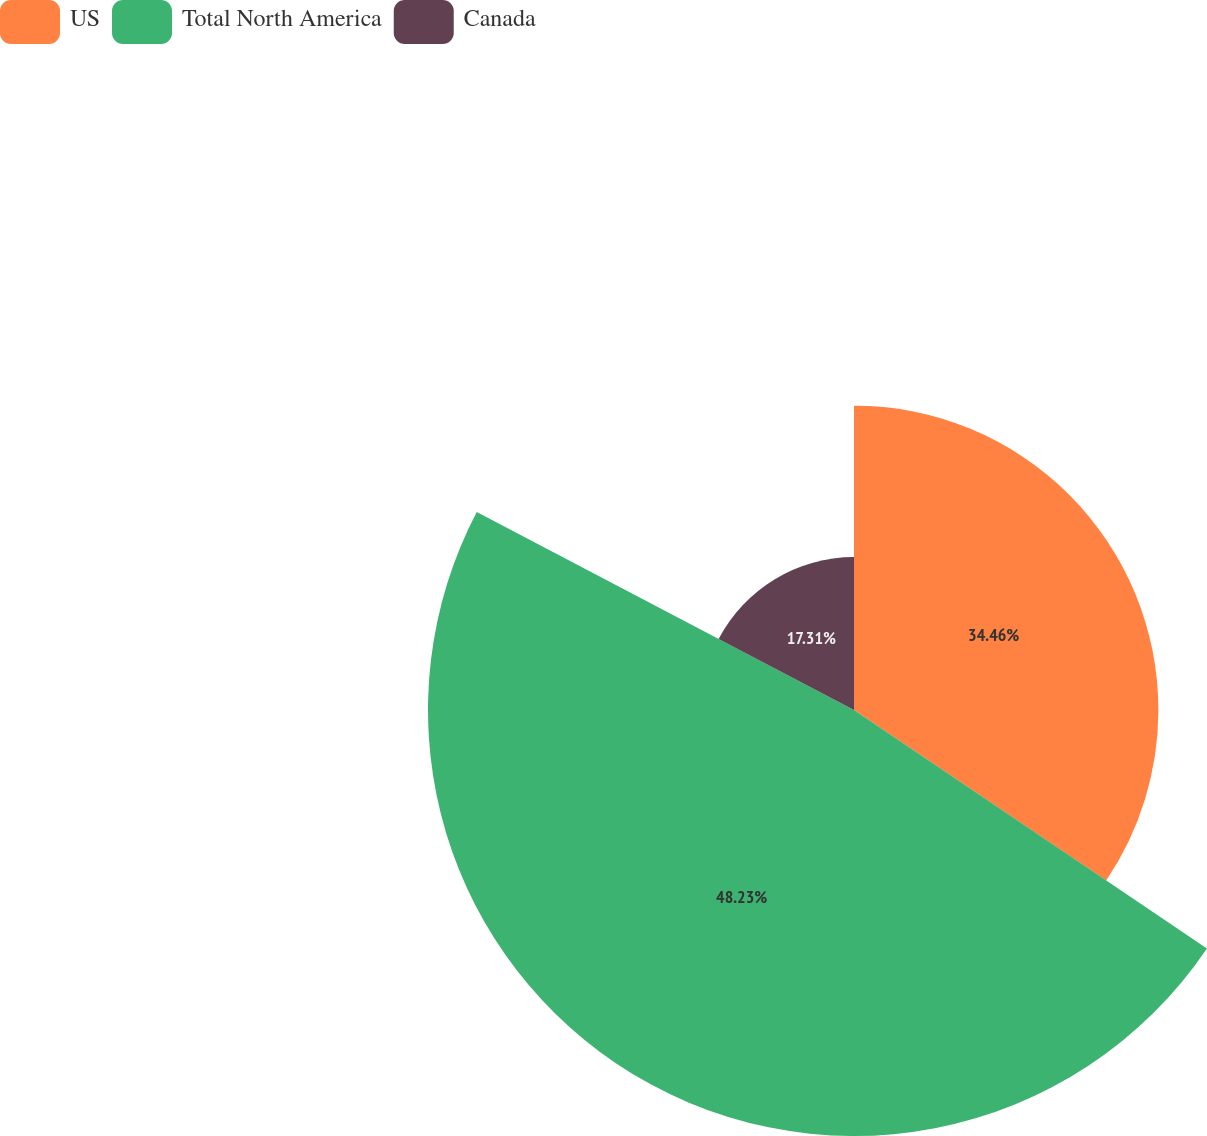Convert chart. <chart><loc_0><loc_0><loc_500><loc_500><pie_chart><fcel>US<fcel>Total North America<fcel>Canada<nl><fcel>34.46%<fcel>48.23%<fcel>17.31%<nl></chart> 